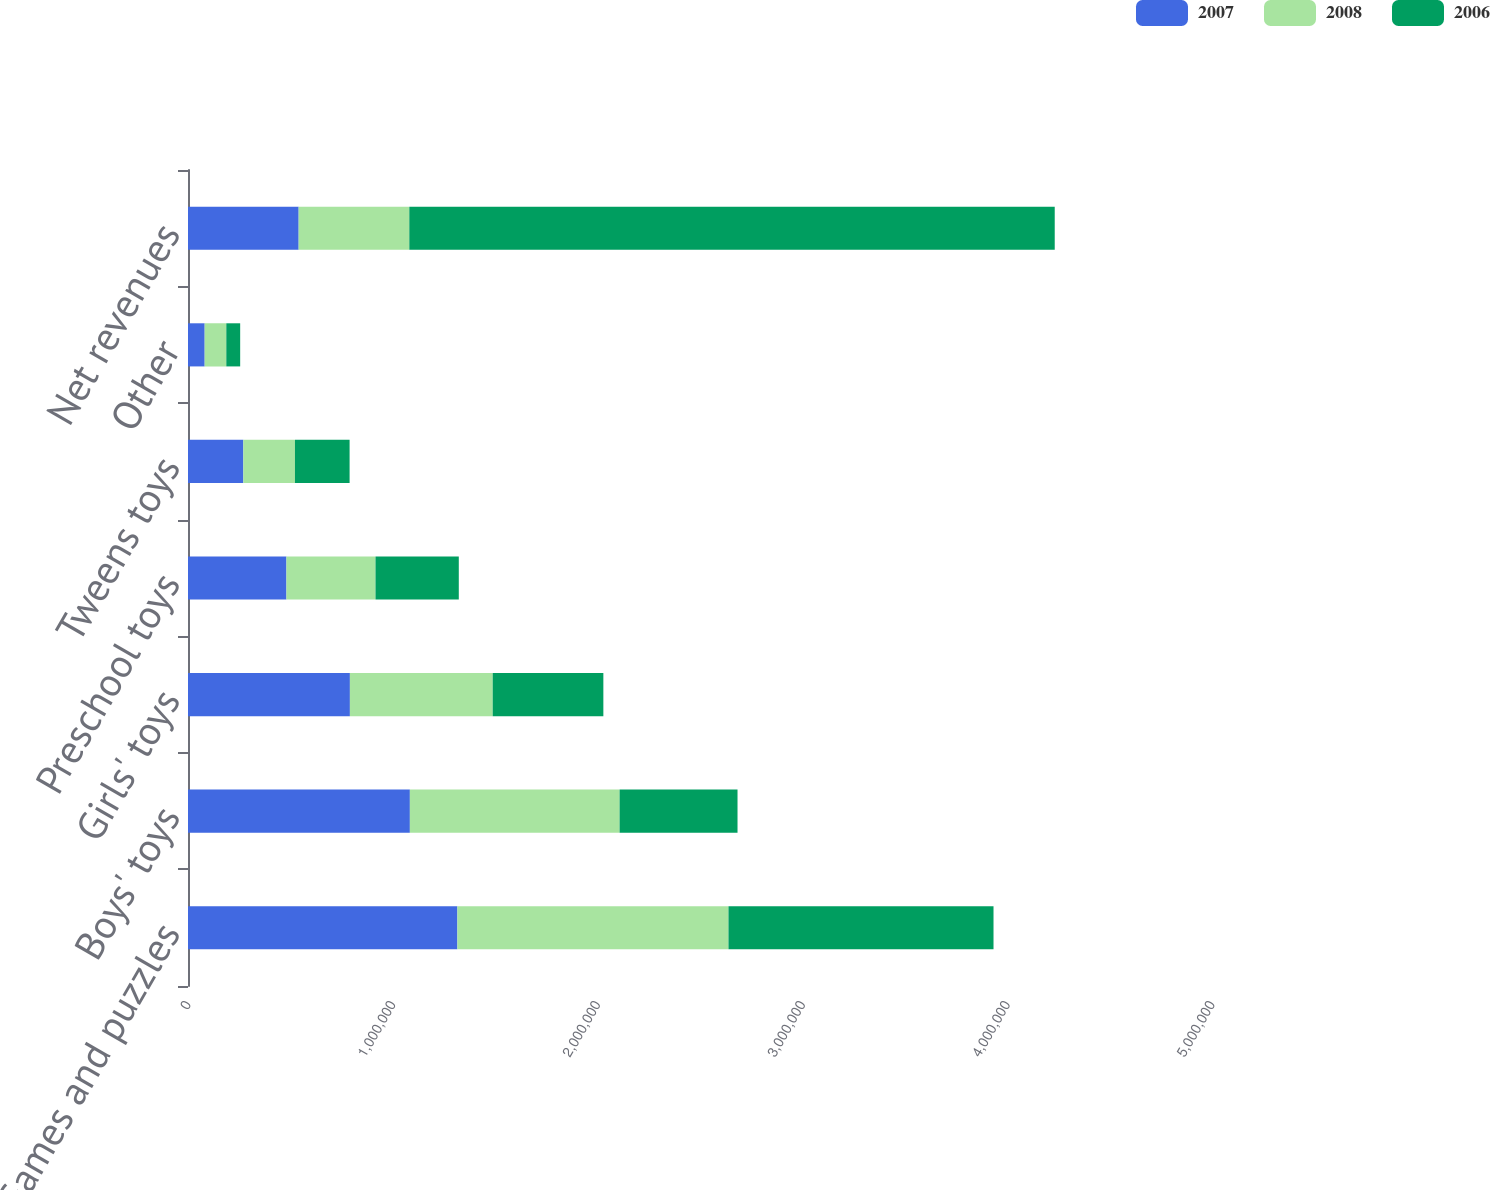Convert chart to OTSL. <chart><loc_0><loc_0><loc_500><loc_500><stacked_bar_chart><ecel><fcel>Games and puzzles<fcel>Boys' toys<fcel>Girls' toys<fcel>Preschool toys<fcel>Tweens toys<fcel>Other<fcel>Net revenues<nl><fcel>2007<fcel>1.31542e+06<fcel>1.08334e+06<fcel>790503<fcel>480694<fcel>270160<fcel>81398<fcel>540298<nl><fcel>2008<fcel>1.32364e+06<fcel>1.02402e+06<fcel>697304<fcel>434893<fcel>252055<fcel>105641<fcel>540298<nl><fcel>2006<fcel>1.29411e+06<fcel>575841<fcel>540298<fcel>406663<fcel>266844<fcel>67725<fcel>3.15148e+06<nl></chart> 